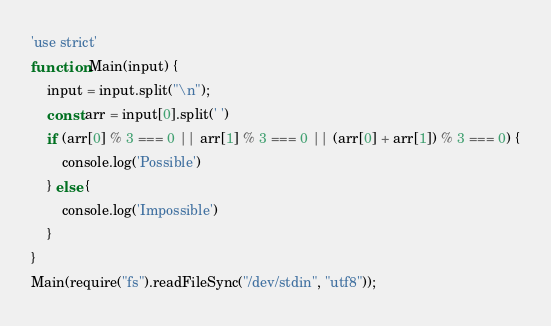Convert code to text. <code><loc_0><loc_0><loc_500><loc_500><_JavaScript_>'use strict'
function Main(input) {
    input = input.split("\n");
    const arr = input[0].split(' ')
    if (arr[0] % 3 === 0 || arr[1] % 3 === 0 || (arr[0] + arr[1]) % 3 === 0) {
        console.log('Possible')
    } else {
        console.log('Impossible')
    }
}
Main(require("fs").readFileSync("/dev/stdin", "utf8"));</code> 